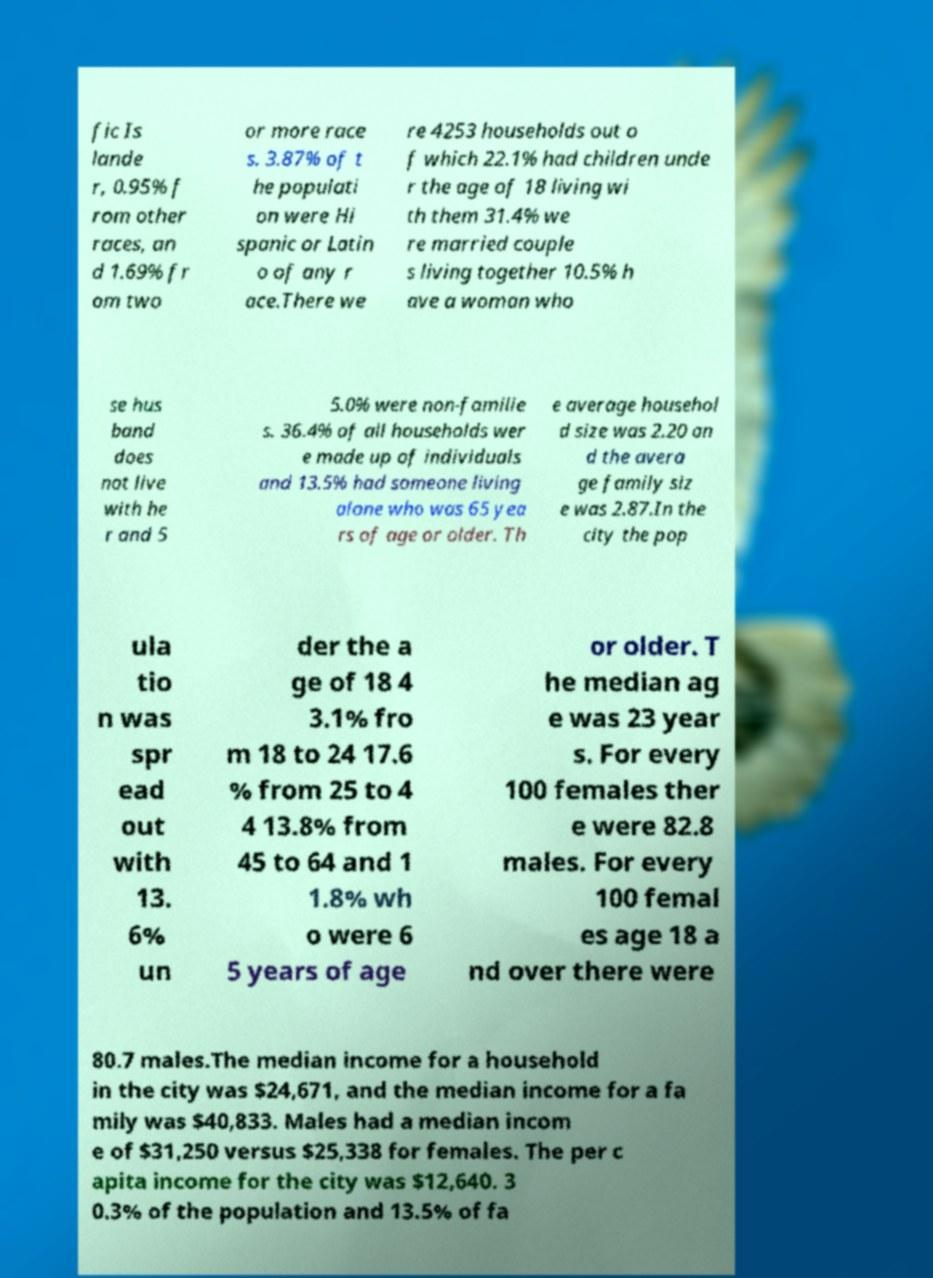Can you read and provide the text displayed in the image?This photo seems to have some interesting text. Can you extract and type it out for me? fic Is lande r, 0.95% f rom other races, an d 1.69% fr om two or more race s. 3.87% of t he populati on were Hi spanic or Latin o of any r ace.There we re 4253 households out o f which 22.1% had children unde r the age of 18 living wi th them 31.4% we re married couple s living together 10.5% h ave a woman who se hus band does not live with he r and 5 5.0% were non-familie s. 36.4% of all households wer e made up of individuals and 13.5% had someone living alone who was 65 yea rs of age or older. Th e average househol d size was 2.20 an d the avera ge family siz e was 2.87.In the city the pop ula tio n was spr ead out with 13. 6% un der the a ge of 18 4 3.1% fro m 18 to 24 17.6 % from 25 to 4 4 13.8% from 45 to 64 and 1 1.8% wh o were 6 5 years of age or older. T he median ag e was 23 year s. For every 100 females ther e were 82.8 males. For every 100 femal es age 18 a nd over there were 80.7 males.The median income for a household in the city was $24,671, and the median income for a fa mily was $40,833. Males had a median incom e of $31,250 versus $25,338 for females. The per c apita income for the city was $12,640. 3 0.3% of the population and 13.5% of fa 